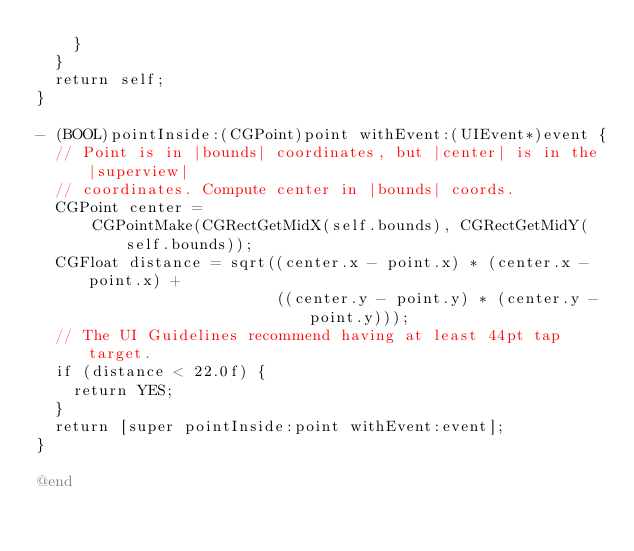Convert code to text. <code><loc_0><loc_0><loc_500><loc_500><_ObjectiveC_>    }
  }
  return self;
}

- (BOOL)pointInside:(CGPoint)point withEvent:(UIEvent*)event {
  // Point is in |bounds| coordinates, but |center| is in the |superview|
  // coordinates. Compute center in |bounds| coords.
  CGPoint center =
      CGPointMake(CGRectGetMidX(self.bounds), CGRectGetMidY(self.bounds));
  CGFloat distance = sqrt((center.x - point.x) * (center.x - point.x) +
                          ((center.y - point.y) * (center.y - point.y)));
  // The UI Guidelines recommend having at least 44pt tap target.
  if (distance < 22.0f) {
    return YES;
  }
  return [super pointInside:point withEvent:event];
}

@end
</code> 